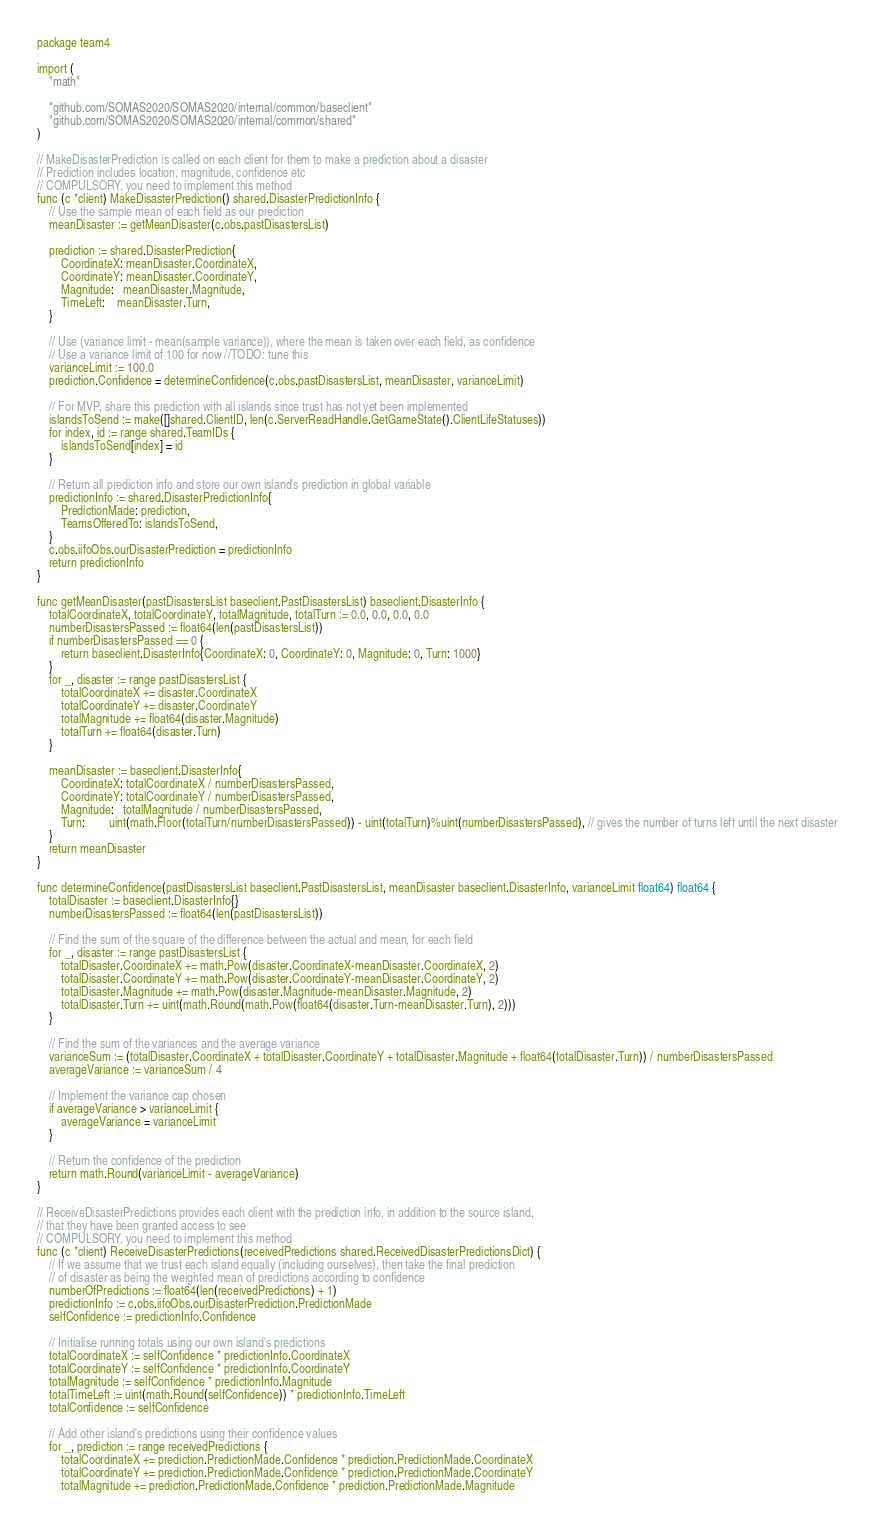<code> <loc_0><loc_0><loc_500><loc_500><_Go_>package team4

import (
	"math"

	"github.com/SOMAS2020/SOMAS2020/internal/common/baseclient"
	"github.com/SOMAS2020/SOMAS2020/internal/common/shared"
)

// MakeDisasterPrediction is called on each client for them to make a prediction about a disaster
// Prediction includes location, magnitude, confidence etc
// COMPULSORY, you need to implement this method
func (c *client) MakeDisasterPrediction() shared.DisasterPredictionInfo {
	// Use the sample mean of each field as our prediction
	meanDisaster := getMeanDisaster(c.obs.pastDisastersList)

	prediction := shared.DisasterPrediction{
		CoordinateX: meanDisaster.CoordinateX,
		CoordinateY: meanDisaster.CoordinateY,
		Magnitude:   meanDisaster.Magnitude,
		TimeLeft:    meanDisaster.Turn,
	}

	// Use (variance limit - mean(sample variance)), where the mean is taken over each field, as confidence
	// Use a variance limit of 100 for now //TODO: tune this
	varianceLimit := 100.0
	prediction.Confidence = determineConfidence(c.obs.pastDisastersList, meanDisaster, varianceLimit)

	// For MVP, share this prediction with all islands since trust has not yet been implemented
	islandsToSend := make([]shared.ClientID, len(c.ServerReadHandle.GetGameState().ClientLifeStatuses))
	for index, id := range shared.TeamIDs {
		islandsToSend[index] = id
	}

	// Return all prediction info and store our own island's prediction in global variable
	predictionInfo := shared.DisasterPredictionInfo{
		PredictionMade: prediction,
		TeamsOfferedTo: islandsToSend,
	}
	c.obs.iifoObs.ourDisasterPrediction = predictionInfo
	return predictionInfo
}

func getMeanDisaster(pastDisastersList baseclient.PastDisastersList) baseclient.DisasterInfo {
	totalCoordinateX, totalCoordinateY, totalMagnitude, totalTurn := 0.0, 0.0, 0.0, 0.0
	numberDisastersPassed := float64(len(pastDisastersList))
	if numberDisastersPassed == 0 {
		return baseclient.DisasterInfo{CoordinateX: 0, CoordinateY: 0, Magnitude: 0, Turn: 1000}
	}
	for _, disaster := range pastDisastersList {
		totalCoordinateX += disaster.CoordinateX
		totalCoordinateY += disaster.CoordinateY
		totalMagnitude += float64(disaster.Magnitude)
		totalTurn += float64(disaster.Turn)
	}

	meanDisaster := baseclient.DisasterInfo{
		CoordinateX: totalCoordinateX / numberDisastersPassed,
		CoordinateY: totalCoordinateY / numberDisastersPassed,
		Magnitude:   totalMagnitude / numberDisastersPassed,
		Turn:        uint(math.Floor(totalTurn/numberDisastersPassed)) - uint(totalTurn)%uint(numberDisastersPassed), // gives the number of turns left until the next disaster
	}
	return meanDisaster
}

func determineConfidence(pastDisastersList baseclient.PastDisastersList, meanDisaster baseclient.DisasterInfo, varianceLimit float64) float64 {
	totalDisaster := baseclient.DisasterInfo{}
	numberDisastersPassed := float64(len(pastDisastersList))

	// Find the sum of the square of the difference between the actual and mean, for each field
	for _, disaster := range pastDisastersList {
		totalDisaster.CoordinateX += math.Pow(disaster.CoordinateX-meanDisaster.CoordinateX, 2)
		totalDisaster.CoordinateY += math.Pow(disaster.CoordinateY-meanDisaster.CoordinateY, 2)
		totalDisaster.Magnitude += math.Pow(disaster.Magnitude-meanDisaster.Magnitude, 2)
		totalDisaster.Turn += uint(math.Round(math.Pow(float64(disaster.Turn-meanDisaster.Turn), 2)))
	}

	// Find the sum of the variances and the average variance
	varianceSum := (totalDisaster.CoordinateX + totalDisaster.CoordinateY + totalDisaster.Magnitude + float64(totalDisaster.Turn)) / numberDisastersPassed
	averageVariance := varianceSum / 4

	// Implement the variance cap chosen
	if averageVariance > varianceLimit {
		averageVariance = varianceLimit
	}

	// Return the confidence of the prediction
	return math.Round(varianceLimit - averageVariance)
}

// ReceiveDisasterPredictions provides each client with the prediction info, in addition to the source island,
// that they have been granted access to see
// COMPULSORY, you need to implement this method
func (c *client) ReceiveDisasterPredictions(receivedPredictions shared.ReceivedDisasterPredictionsDict) {
	// If we assume that we trust each island equally (including ourselves), then take the final prediction
	// of disaster as being the weighted mean of predictions according to confidence
	numberOfPredictions := float64(len(receivedPredictions) + 1)
	predictionInfo := c.obs.iifoObs.ourDisasterPrediction.PredictionMade
	selfConfidence := predictionInfo.Confidence

	// Initialise running totals using our own island's predictions
	totalCoordinateX := selfConfidence * predictionInfo.CoordinateX
	totalCoordinateY := selfConfidence * predictionInfo.CoordinateY
	totalMagnitude := selfConfidence * predictionInfo.Magnitude
	totalTimeLeft := uint(math.Round(selfConfidence)) * predictionInfo.TimeLeft
	totalConfidence := selfConfidence

	// Add other island's predictions using their confidence values
	for _, prediction := range receivedPredictions {
		totalCoordinateX += prediction.PredictionMade.Confidence * prediction.PredictionMade.CoordinateX
		totalCoordinateY += prediction.PredictionMade.Confidence * prediction.PredictionMade.CoordinateY
		totalMagnitude += prediction.PredictionMade.Confidence * prediction.PredictionMade.Magnitude</code> 